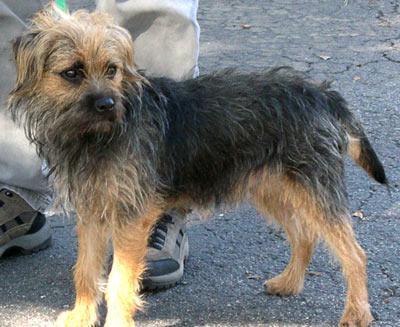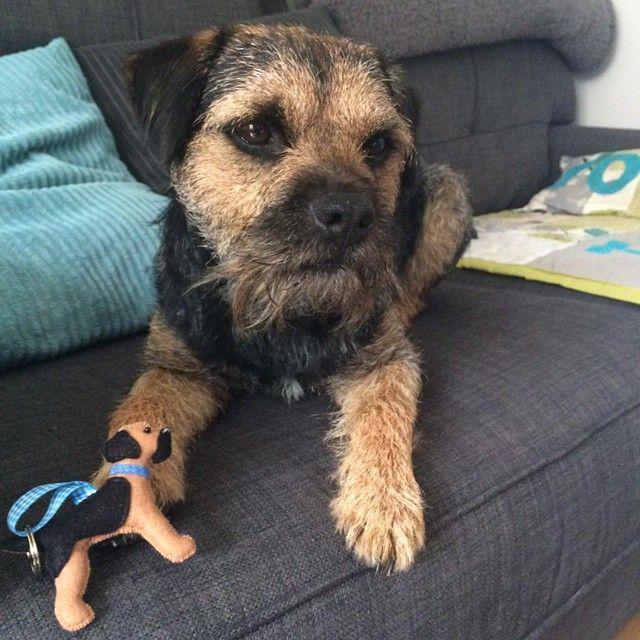The first image is the image on the left, the second image is the image on the right. Considering the images on both sides, is "One dog is standing in the grass." valid? Answer yes or no. No. The first image is the image on the left, the second image is the image on the right. Evaluate the accuracy of this statement regarding the images: "The left image shows a dog with head and body in profile and its tail extended out, and the right image shows a puppy with its tail sticking out behind it.". Is it true? Answer yes or no. No. 